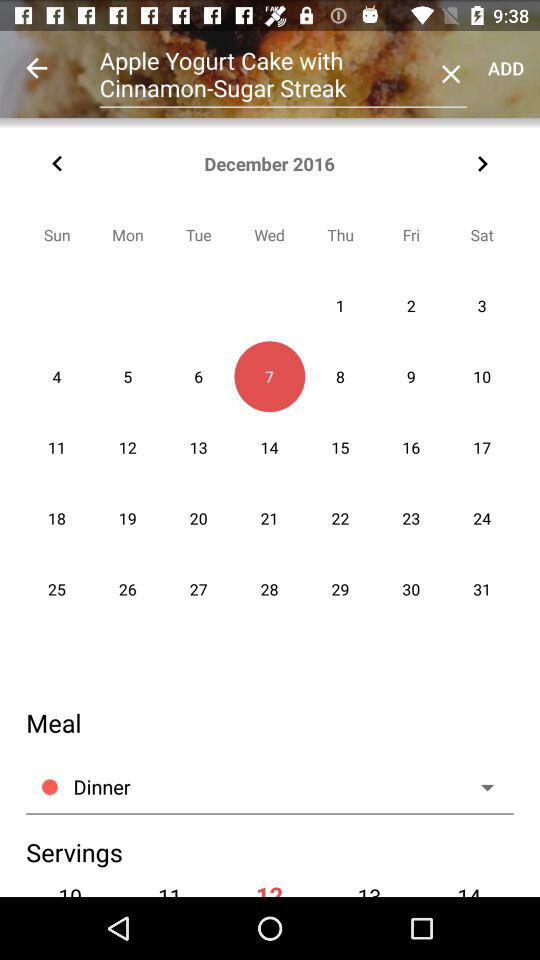What is the name of the dish? The name of the dish is Apple Yogurt Cake with Cinnamon-Sugar Streak. 